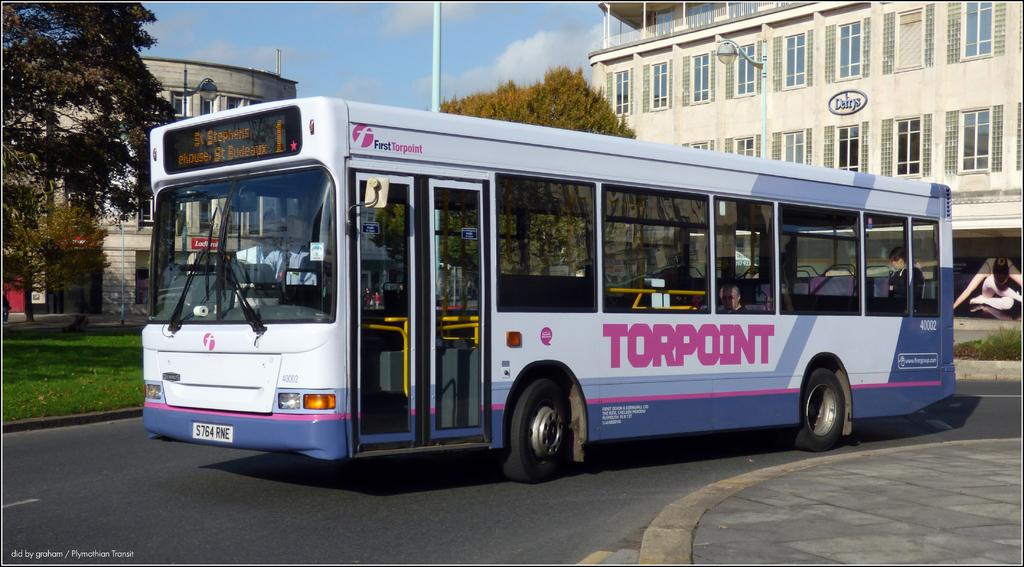<image>
Create a compact narrative representing the image presented. a white, purple and pink city bus with the words TORPOINT is on the street 